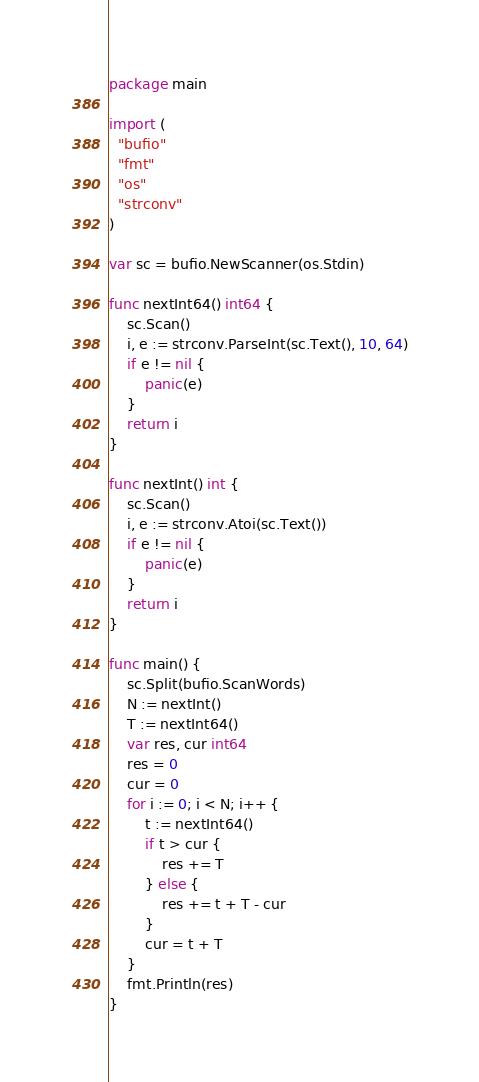Convert code to text. <code><loc_0><loc_0><loc_500><loc_500><_Go_>package main

import (
  "bufio"
  "fmt"
  "os"
  "strconv"
)

var sc = bufio.NewScanner(os.Stdin)

func nextInt64() int64 {
    sc.Scan()
    i, e := strconv.ParseInt(sc.Text(), 10, 64)
    if e != nil {
        panic(e)
    }
    return i
}

func nextInt() int {
    sc.Scan()
    i, e := strconv.Atoi(sc.Text())
    if e != nil {
        panic(e)
    }
    return i
}

func main() {
    sc.Split(bufio.ScanWords)
    N := nextInt()
    T := nextInt64()
    var res, cur int64
    res = 0
    cur = 0
    for i := 0; i < N; i++ {
        t := nextInt64()
        if t > cur {
            res += T
        } else {
            res += t + T - cur
        }
        cur = t + T
    }
    fmt.Println(res)
}
</code> 